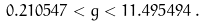Convert formula to latex. <formula><loc_0><loc_0><loc_500><loc_500>0 . 2 1 0 5 4 7 < g < 1 1 . 4 9 5 4 9 4 \, .</formula> 